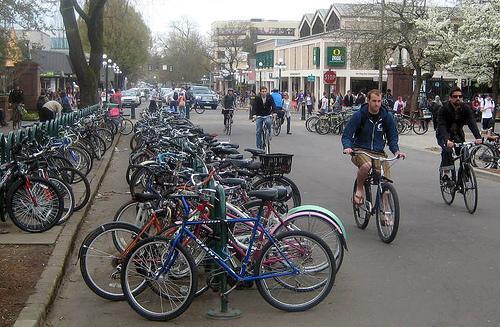How many 'bike baskets' are there in the photo?
Give a very brief answer. 1. How many bicycles are in the picture?
Give a very brief answer. 5. How many people are there?
Give a very brief answer. 3. How many stickers is on the suitcase to the left?
Give a very brief answer. 0. 